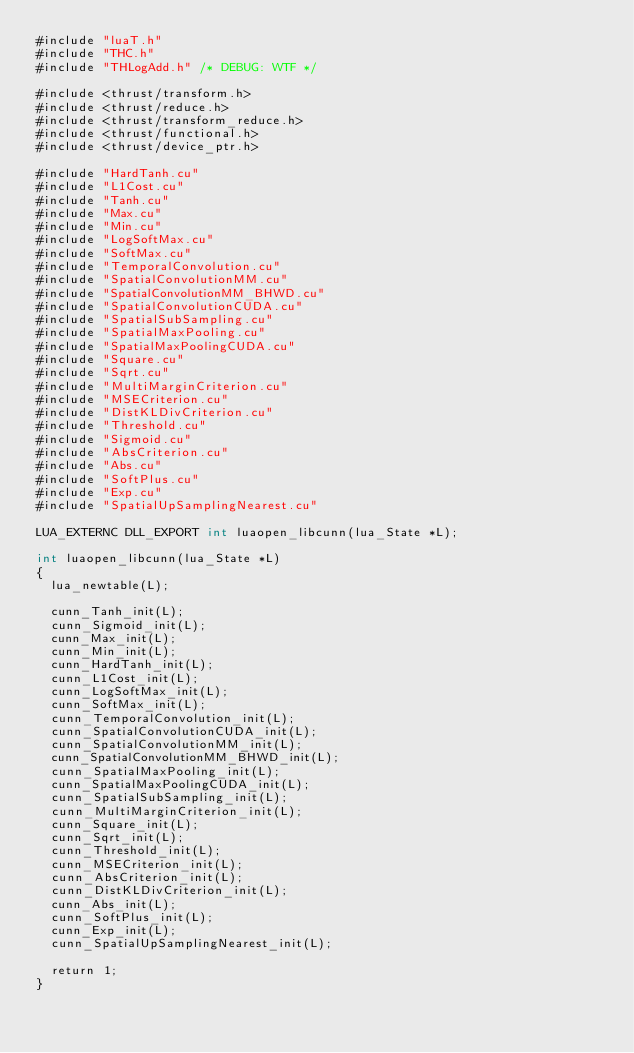<code> <loc_0><loc_0><loc_500><loc_500><_Cuda_>#include "luaT.h"
#include "THC.h"
#include "THLogAdd.h" /* DEBUG: WTF */

#include <thrust/transform.h>
#include <thrust/reduce.h>
#include <thrust/transform_reduce.h>
#include <thrust/functional.h>
#include <thrust/device_ptr.h>

#include "HardTanh.cu"
#include "L1Cost.cu"
#include "Tanh.cu"
#include "Max.cu"
#include "Min.cu"
#include "LogSoftMax.cu"
#include "SoftMax.cu"
#include "TemporalConvolution.cu"
#include "SpatialConvolutionMM.cu"
#include "SpatialConvolutionMM_BHWD.cu"
#include "SpatialConvolutionCUDA.cu"
#include "SpatialSubSampling.cu"
#include "SpatialMaxPooling.cu"
#include "SpatialMaxPoolingCUDA.cu"
#include "Square.cu"
#include "Sqrt.cu"
#include "MultiMarginCriterion.cu"
#include "MSECriterion.cu"
#include "DistKLDivCriterion.cu"
#include "Threshold.cu"
#include "Sigmoid.cu"
#include "AbsCriterion.cu"
#include "Abs.cu"
#include "SoftPlus.cu"
#include "Exp.cu"
#include "SpatialUpSamplingNearest.cu"

LUA_EXTERNC DLL_EXPORT int luaopen_libcunn(lua_State *L);

int luaopen_libcunn(lua_State *L)
{
  lua_newtable(L);

  cunn_Tanh_init(L);
  cunn_Sigmoid_init(L);
  cunn_Max_init(L);
  cunn_Min_init(L);
  cunn_HardTanh_init(L);
  cunn_L1Cost_init(L);
  cunn_LogSoftMax_init(L);
  cunn_SoftMax_init(L);
  cunn_TemporalConvolution_init(L);
  cunn_SpatialConvolutionCUDA_init(L);
  cunn_SpatialConvolutionMM_init(L);
  cunn_SpatialConvolutionMM_BHWD_init(L);
  cunn_SpatialMaxPooling_init(L);
  cunn_SpatialMaxPoolingCUDA_init(L);
  cunn_SpatialSubSampling_init(L);
  cunn_MultiMarginCriterion_init(L);
  cunn_Square_init(L);
  cunn_Sqrt_init(L);
  cunn_Threshold_init(L);
  cunn_MSECriterion_init(L);
  cunn_AbsCriterion_init(L);
  cunn_DistKLDivCriterion_init(L);
  cunn_Abs_init(L);
  cunn_SoftPlus_init(L);
  cunn_Exp_init(L);
  cunn_SpatialUpSamplingNearest_init(L);

  return 1;
}
</code> 